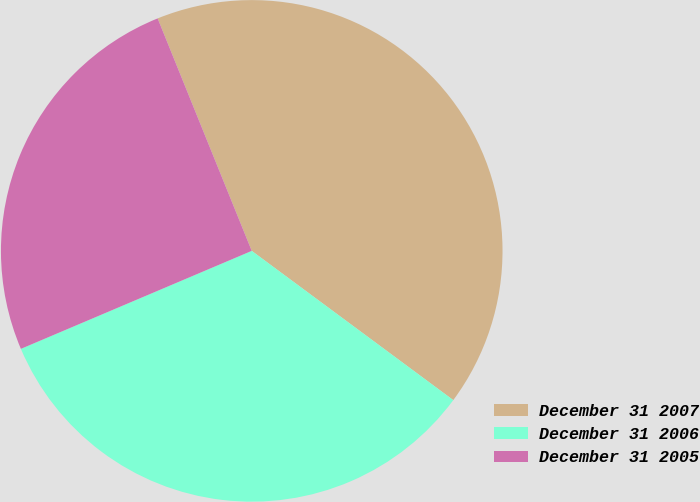Convert chart to OTSL. <chart><loc_0><loc_0><loc_500><loc_500><pie_chart><fcel>December 31 2007<fcel>December 31 2006<fcel>December 31 2005<nl><fcel>41.27%<fcel>33.47%<fcel>25.27%<nl></chart> 